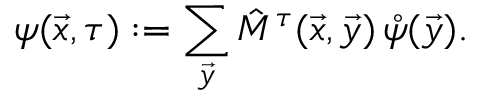<formula> <loc_0><loc_0><loc_500><loc_500>\psi ( \vec { x } , \tau ) \colon = \sum _ { \vec { y } } \hat { M } ^ { \tau } ( \vec { x } , \vec { y } ) \, \mathring { \psi } ( \vec { y } ) .</formula> 